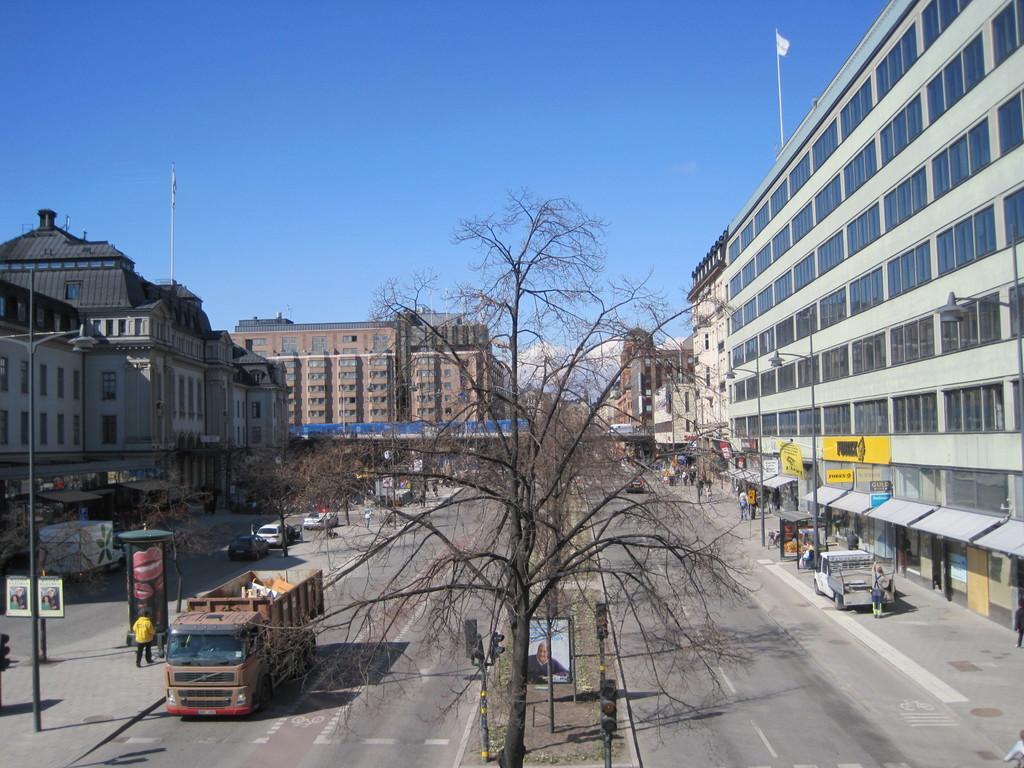How would you summarize this image in a sentence or two? Here in this picture we can see buildings present all over there and in the middle we can see road, on which we can see vehicles present and we can also see people standing and walking over there and we can also see flag post on either side of the building over there and we can see trees and plants also present and we can see traffic signal lights, hoarding, sign boards all present over there. 